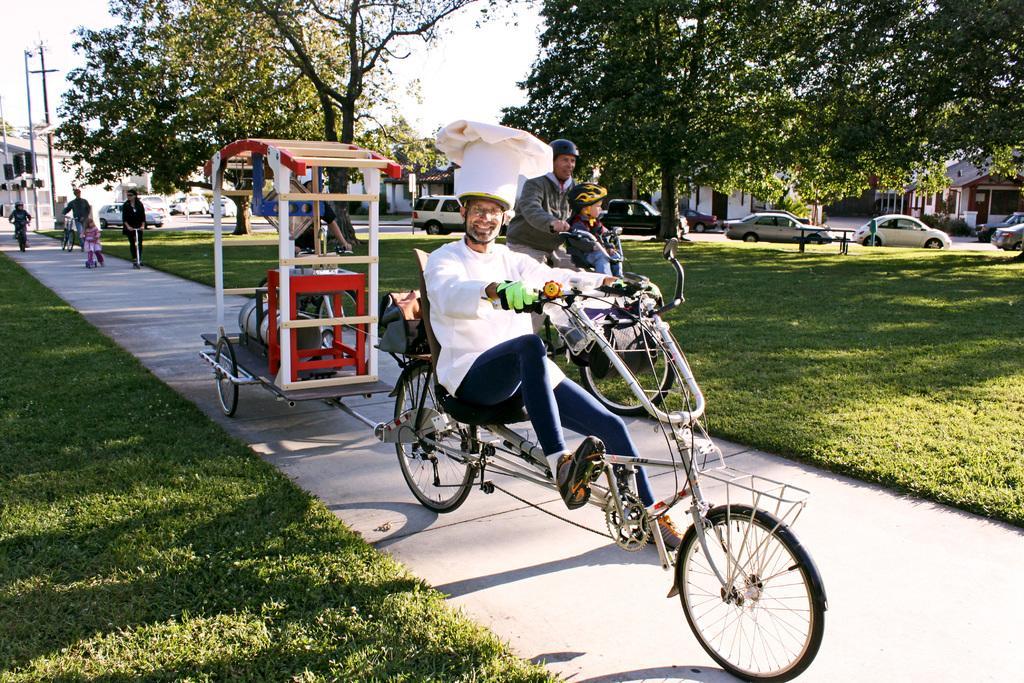Can you describe this image briefly? In the center of the image there are people cycling on the road. On both right and left side of the image there is grass on the surface. On the right side of the image there are cars parked on the road. There are current polls. In the background of the image there are trees, buildings and sky. 